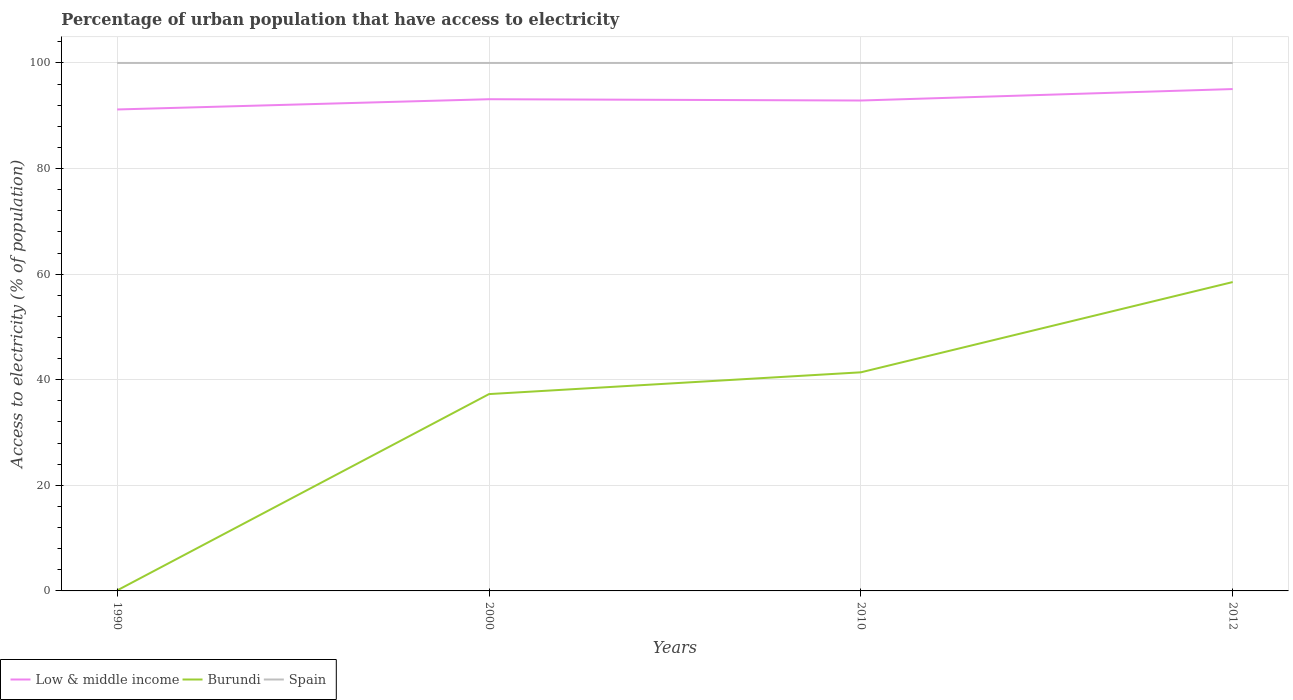How many different coloured lines are there?
Provide a succinct answer. 3. Does the line corresponding to Low & middle income intersect with the line corresponding to Spain?
Ensure brevity in your answer.  No. Is the number of lines equal to the number of legend labels?
Your response must be concise. Yes. Across all years, what is the maximum percentage of urban population that have access to electricity in Low & middle income?
Your answer should be compact. 91.19. In which year was the percentage of urban population that have access to electricity in Low & middle income maximum?
Ensure brevity in your answer.  1990. What is the total percentage of urban population that have access to electricity in Low & middle income in the graph?
Provide a short and direct response. -2.17. What is the difference between the highest and the second highest percentage of urban population that have access to electricity in Spain?
Ensure brevity in your answer.  0. Is the percentage of urban population that have access to electricity in Low & middle income strictly greater than the percentage of urban population that have access to electricity in Spain over the years?
Your answer should be compact. Yes. Are the values on the major ticks of Y-axis written in scientific E-notation?
Provide a short and direct response. No. What is the title of the graph?
Your answer should be very brief. Percentage of urban population that have access to electricity. Does "Finland" appear as one of the legend labels in the graph?
Give a very brief answer. No. What is the label or title of the X-axis?
Keep it short and to the point. Years. What is the label or title of the Y-axis?
Keep it short and to the point. Access to electricity (% of population). What is the Access to electricity (% of population) of Low & middle income in 1990?
Your answer should be compact. 91.19. What is the Access to electricity (% of population) in Burundi in 1990?
Your response must be concise. 0.1. What is the Access to electricity (% of population) in Spain in 1990?
Your answer should be very brief. 100. What is the Access to electricity (% of population) in Low & middle income in 2000?
Your answer should be very brief. 93.13. What is the Access to electricity (% of population) in Burundi in 2000?
Ensure brevity in your answer.  37.28. What is the Access to electricity (% of population) of Low & middle income in 2010?
Your response must be concise. 92.88. What is the Access to electricity (% of population) in Burundi in 2010?
Make the answer very short. 41.41. What is the Access to electricity (% of population) of Spain in 2010?
Keep it short and to the point. 100. What is the Access to electricity (% of population) in Low & middle income in 2012?
Ensure brevity in your answer.  95.06. What is the Access to electricity (% of population) in Burundi in 2012?
Your answer should be compact. 58.5. Across all years, what is the maximum Access to electricity (% of population) of Low & middle income?
Provide a succinct answer. 95.06. Across all years, what is the maximum Access to electricity (% of population) of Burundi?
Make the answer very short. 58.5. Across all years, what is the maximum Access to electricity (% of population) of Spain?
Make the answer very short. 100. Across all years, what is the minimum Access to electricity (% of population) in Low & middle income?
Your answer should be very brief. 91.19. Across all years, what is the minimum Access to electricity (% of population) of Burundi?
Keep it short and to the point. 0.1. What is the total Access to electricity (% of population) of Low & middle income in the graph?
Your answer should be compact. 372.26. What is the total Access to electricity (% of population) of Burundi in the graph?
Provide a succinct answer. 137.29. What is the total Access to electricity (% of population) of Spain in the graph?
Your answer should be very brief. 400. What is the difference between the Access to electricity (% of population) of Low & middle income in 1990 and that in 2000?
Give a very brief answer. -1.94. What is the difference between the Access to electricity (% of population) in Burundi in 1990 and that in 2000?
Provide a short and direct response. -37.18. What is the difference between the Access to electricity (% of population) in Low & middle income in 1990 and that in 2010?
Keep it short and to the point. -1.69. What is the difference between the Access to electricity (% of population) of Burundi in 1990 and that in 2010?
Your response must be concise. -41.31. What is the difference between the Access to electricity (% of population) of Low & middle income in 1990 and that in 2012?
Offer a very short reply. -3.87. What is the difference between the Access to electricity (% of population) in Burundi in 1990 and that in 2012?
Offer a terse response. -58.4. What is the difference between the Access to electricity (% of population) of Spain in 1990 and that in 2012?
Keep it short and to the point. 0. What is the difference between the Access to electricity (% of population) in Low & middle income in 2000 and that in 2010?
Provide a short and direct response. 0.25. What is the difference between the Access to electricity (% of population) of Burundi in 2000 and that in 2010?
Keep it short and to the point. -4.12. What is the difference between the Access to electricity (% of population) of Low & middle income in 2000 and that in 2012?
Your response must be concise. -1.93. What is the difference between the Access to electricity (% of population) in Burundi in 2000 and that in 2012?
Your answer should be very brief. -21.22. What is the difference between the Access to electricity (% of population) in Spain in 2000 and that in 2012?
Make the answer very short. 0. What is the difference between the Access to electricity (% of population) in Low & middle income in 2010 and that in 2012?
Your response must be concise. -2.17. What is the difference between the Access to electricity (% of population) of Burundi in 2010 and that in 2012?
Your answer should be compact. -17.09. What is the difference between the Access to electricity (% of population) in Low & middle income in 1990 and the Access to electricity (% of population) in Burundi in 2000?
Give a very brief answer. 53.91. What is the difference between the Access to electricity (% of population) of Low & middle income in 1990 and the Access to electricity (% of population) of Spain in 2000?
Keep it short and to the point. -8.81. What is the difference between the Access to electricity (% of population) in Burundi in 1990 and the Access to electricity (% of population) in Spain in 2000?
Offer a terse response. -99.9. What is the difference between the Access to electricity (% of population) of Low & middle income in 1990 and the Access to electricity (% of population) of Burundi in 2010?
Keep it short and to the point. 49.78. What is the difference between the Access to electricity (% of population) of Low & middle income in 1990 and the Access to electricity (% of population) of Spain in 2010?
Provide a short and direct response. -8.81. What is the difference between the Access to electricity (% of population) of Burundi in 1990 and the Access to electricity (% of population) of Spain in 2010?
Provide a succinct answer. -99.9. What is the difference between the Access to electricity (% of population) of Low & middle income in 1990 and the Access to electricity (% of population) of Burundi in 2012?
Your response must be concise. 32.69. What is the difference between the Access to electricity (% of population) in Low & middle income in 1990 and the Access to electricity (% of population) in Spain in 2012?
Make the answer very short. -8.81. What is the difference between the Access to electricity (% of population) in Burundi in 1990 and the Access to electricity (% of population) in Spain in 2012?
Give a very brief answer. -99.9. What is the difference between the Access to electricity (% of population) in Low & middle income in 2000 and the Access to electricity (% of population) in Burundi in 2010?
Offer a terse response. 51.72. What is the difference between the Access to electricity (% of population) of Low & middle income in 2000 and the Access to electricity (% of population) of Spain in 2010?
Make the answer very short. -6.87. What is the difference between the Access to electricity (% of population) in Burundi in 2000 and the Access to electricity (% of population) in Spain in 2010?
Provide a succinct answer. -62.72. What is the difference between the Access to electricity (% of population) in Low & middle income in 2000 and the Access to electricity (% of population) in Burundi in 2012?
Your response must be concise. 34.63. What is the difference between the Access to electricity (% of population) in Low & middle income in 2000 and the Access to electricity (% of population) in Spain in 2012?
Give a very brief answer. -6.87. What is the difference between the Access to electricity (% of population) in Burundi in 2000 and the Access to electricity (% of population) in Spain in 2012?
Your answer should be compact. -62.72. What is the difference between the Access to electricity (% of population) in Low & middle income in 2010 and the Access to electricity (% of population) in Burundi in 2012?
Offer a very short reply. 34.38. What is the difference between the Access to electricity (% of population) in Low & middle income in 2010 and the Access to electricity (% of population) in Spain in 2012?
Ensure brevity in your answer.  -7.12. What is the difference between the Access to electricity (% of population) of Burundi in 2010 and the Access to electricity (% of population) of Spain in 2012?
Ensure brevity in your answer.  -58.59. What is the average Access to electricity (% of population) of Low & middle income per year?
Your answer should be very brief. 93.06. What is the average Access to electricity (% of population) of Burundi per year?
Make the answer very short. 34.32. In the year 1990, what is the difference between the Access to electricity (% of population) of Low & middle income and Access to electricity (% of population) of Burundi?
Provide a succinct answer. 91.09. In the year 1990, what is the difference between the Access to electricity (% of population) in Low & middle income and Access to electricity (% of population) in Spain?
Give a very brief answer. -8.81. In the year 1990, what is the difference between the Access to electricity (% of population) in Burundi and Access to electricity (% of population) in Spain?
Your answer should be compact. -99.9. In the year 2000, what is the difference between the Access to electricity (% of population) in Low & middle income and Access to electricity (% of population) in Burundi?
Your answer should be compact. 55.85. In the year 2000, what is the difference between the Access to electricity (% of population) of Low & middle income and Access to electricity (% of population) of Spain?
Your answer should be very brief. -6.87. In the year 2000, what is the difference between the Access to electricity (% of population) in Burundi and Access to electricity (% of population) in Spain?
Your answer should be very brief. -62.72. In the year 2010, what is the difference between the Access to electricity (% of population) in Low & middle income and Access to electricity (% of population) in Burundi?
Give a very brief answer. 51.48. In the year 2010, what is the difference between the Access to electricity (% of population) of Low & middle income and Access to electricity (% of population) of Spain?
Provide a short and direct response. -7.12. In the year 2010, what is the difference between the Access to electricity (% of population) of Burundi and Access to electricity (% of population) of Spain?
Give a very brief answer. -58.59. In the year 2012, what is the difference between the Access to electricity (% of population) in Low & middle income and Access to electricity (% of population) in Burundi?
Make the answer very short. 36.56. In the year 2012, what is the difference between the Access to electricity (% of population) in Low & middle income and Access to electricity (% of population) in Spain?
Offer a very short reply. -4.94. In the year 2012, what is the difference between the Access to electricity (% of population) of Burundi and Access to electricity (% of population) of Spain?
Give a very brief answer. -41.5. What is the ratio of the Access to electricity (% of population) of Low & middle income in 1990 to that in 2000?
Your answer should be very brief. 0.98. What is the ratio of the Access to electricity (% of population) in Burundi in 1990 to that in 2000?
Your answer should be compact. 0. What is the ratio of the Access to electricity (% of population) of Spain in 1990 to that in 2000?
Provide a short and direct response. 1. What is the ratio of the Access to electricity (% of population) in Low & middle income in 1990 to that in 2010?
Ensure brevity in your answer.  0.98. What is the ratio of the Access to electricity (% of population) of Burundi in 1990 to that in 2010?
Ensure brevity in your answer.  0. What is the ratio of the Access to electricity (% of population) of Low & middle income in 1990 to that in 2012?
Ensure brevity in your answer.  0.96. What is the ratio of the Access to electricity (% of population) in Burundi in 1990 to that in 2012?
Keep it short and to the point. 0. What is the ratio of the Access to electricity (% of population) of Spain in 1990 to that in 2012?
Ensure brevity in your answer.  1. What is the ratio of the Access to electricity (% of population) in Low & middle income in 2000 to that in 2010?
Provide a short and direct response. 1. What is the ratio of the Access to electricity (% of population) in Burundi in 2000 to that in 2010?
Give a very brief answer. 0.9. What is the ratio of the Access to electricity (% of population) of Low & middle income in 2000 to that in 2012?
Your answer should be very brief. 0.98. What is the ratio of the Access to electricity (% of population) in Burundi in 2000 to that in 2012?
Make the answer very short. 0.64. What is the ratio of the Access to electricity (% of population) of Low & middle income in 2010 to that in 2012?
Your answer should be very brief. 0.98. What is the ratio of the Access to electricity (% of population) in Burundi in 2010 to that in 2012?
Provide a succinct answer. 0.71. What is the ratio of the Access to electricity (% of population) in Spain in 2010 to that in 2012?
Make the answer very short. 1. What is the difference between the highest and the second highest Access to electricity (% of population) in Low & middle income?
Make the answer very short. 1.93. What is the difference between the highest and the second highest Access to electricity (% of population) in Burundi?
Make the answer very short. 17.09. What is the difference between the highest and the lowest Access to electricity (% of population) of Low & middle income?
Give a very brief answer. 3.87. What is the difference between the highest and the lowest Access to electricity (% of population) in Burundi?
Your answer should be very brief. 58.4. 